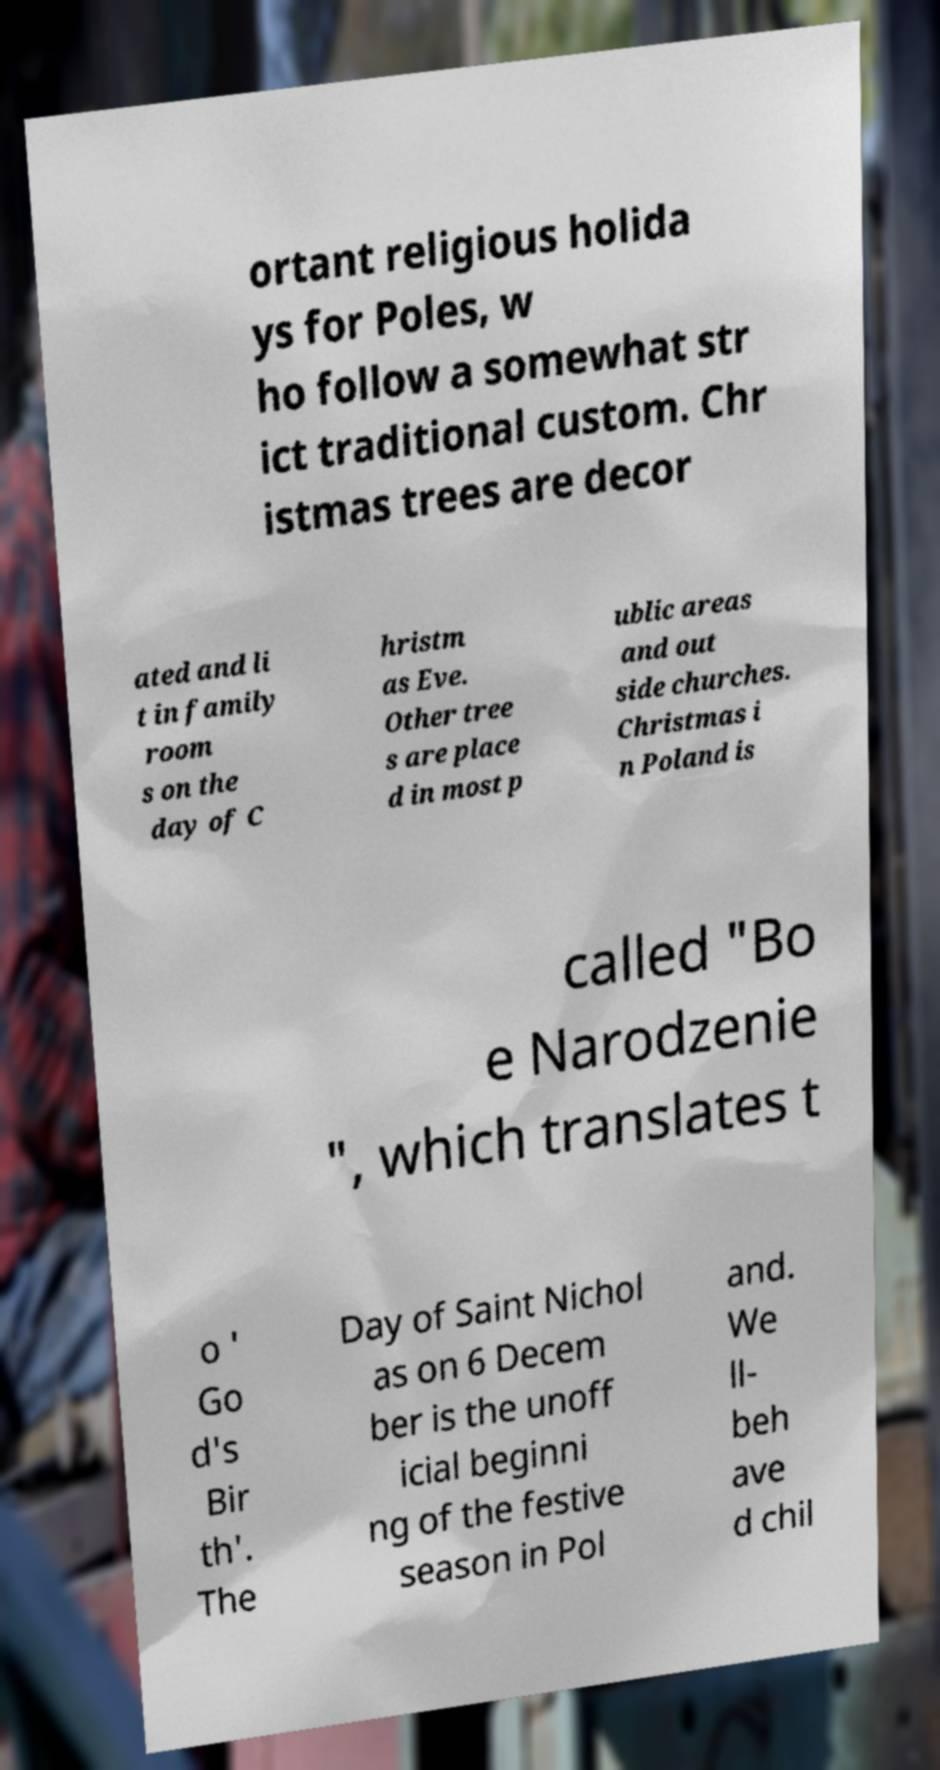Could you assist in decoding the text presented in this image and type it out clearly? ortant religious holida ys for Poles, w ho follow a somewhat str ict traditional custom. Chr istmas trees are decor ated and li t in family room s on the day of C hristm as Eve. Other tree s are place d in most p ublic areas and out side churches. Christmas i n Poland is called "Bo e Narodzenie ", which translates t o ' Go d's Bir th'. The Day of Saint Nichol as on 6 Decem ber is the unoff icial beginni ng of the festive season in Pol and. We ll- beh ave d chil 